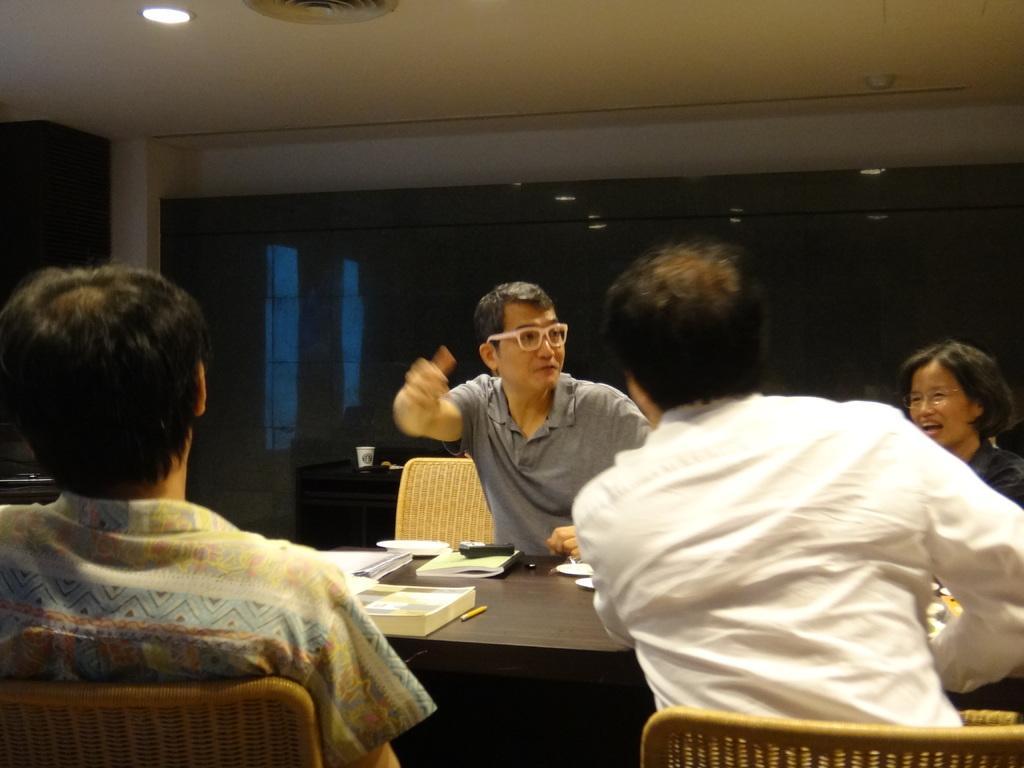In one or two sentences, can you explain what this image depicts? In this picture there is a man wearing grey color t-shirt sitting on the chair and taking. In the front there is a table with some bottles and two person sitting on the chair and watching to him. In the background there is a glass wall. 